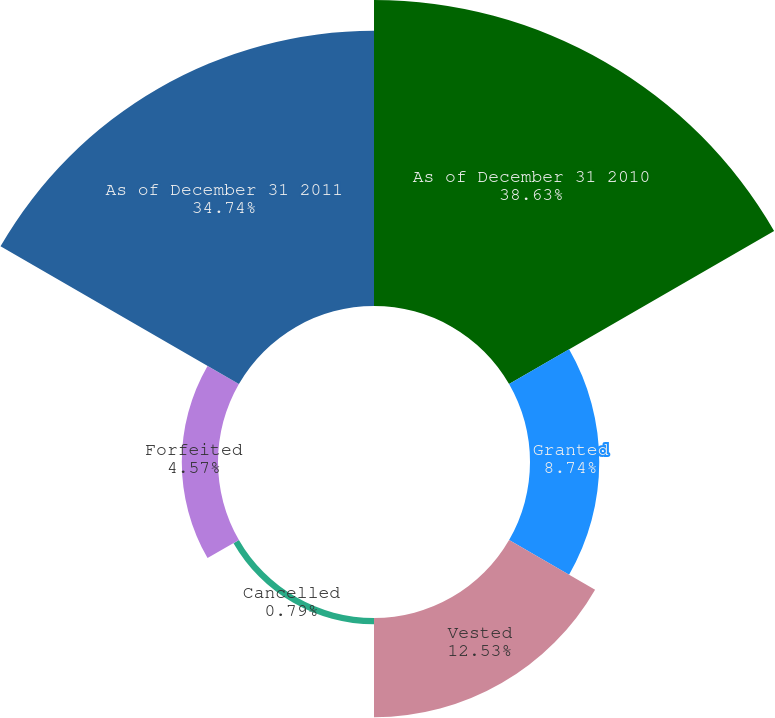<chart> <loc_0><loc_0><loc_500><loc_500><pie_chart><fcel>As of December 31 2010<fcel>Granted<fcel>Vested<fcel>Cancelled<fcel>Forfeited<fcel>As of December 31 2011<nl><fcel>38.62%<fcel>8.74%<fcel>12.53%<fcel>0.79%<fcel>4.57%<fcel>34.74%<nl></chart> 